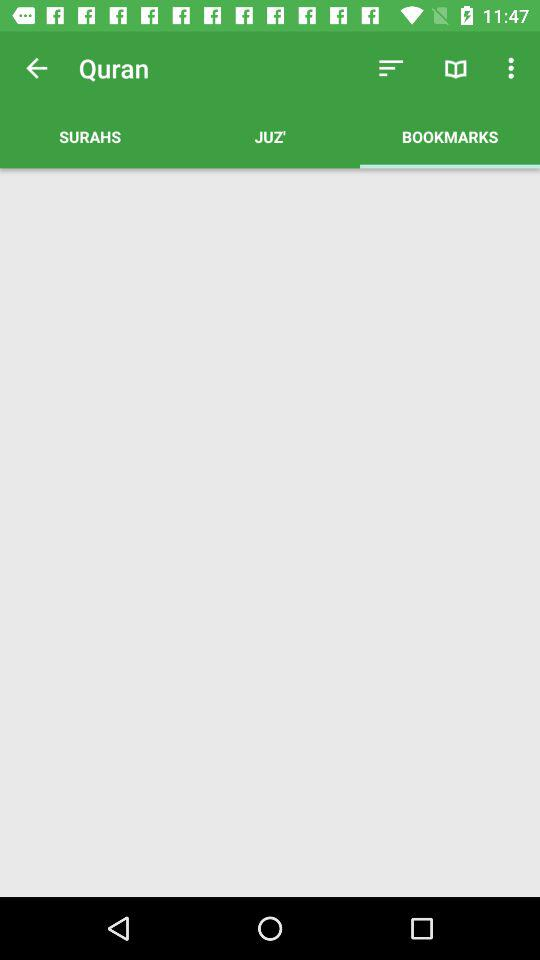What is the selected tab? The selected tab is "BOOKMARKS". 